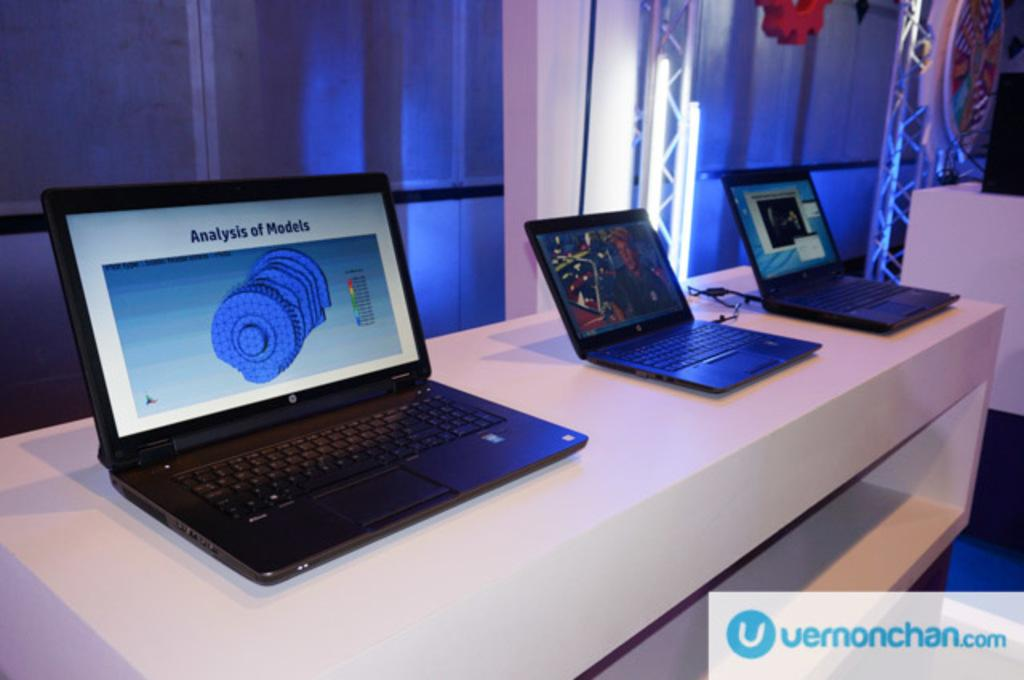<image>
Create a compact narrative representing the image presented. A laptop reads "Analysis of Models" on the screen. 